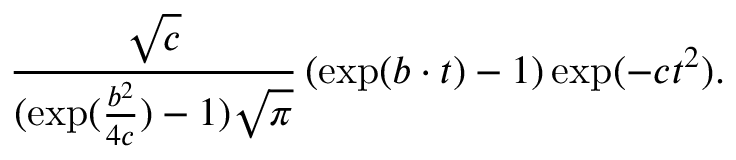<formula> <loc_0><loc_0><loc_500><loc_500>\frac { \sqrt { c } } { ( \exp ( \frac { b ^ { 2 } } { 4 c } ) - 1 ) \sqrt { \pi } } \left ( \exp ( b \cdot t ) - 1 \right ) \exp ( - c t ^ { 2 } ) .</formula> 